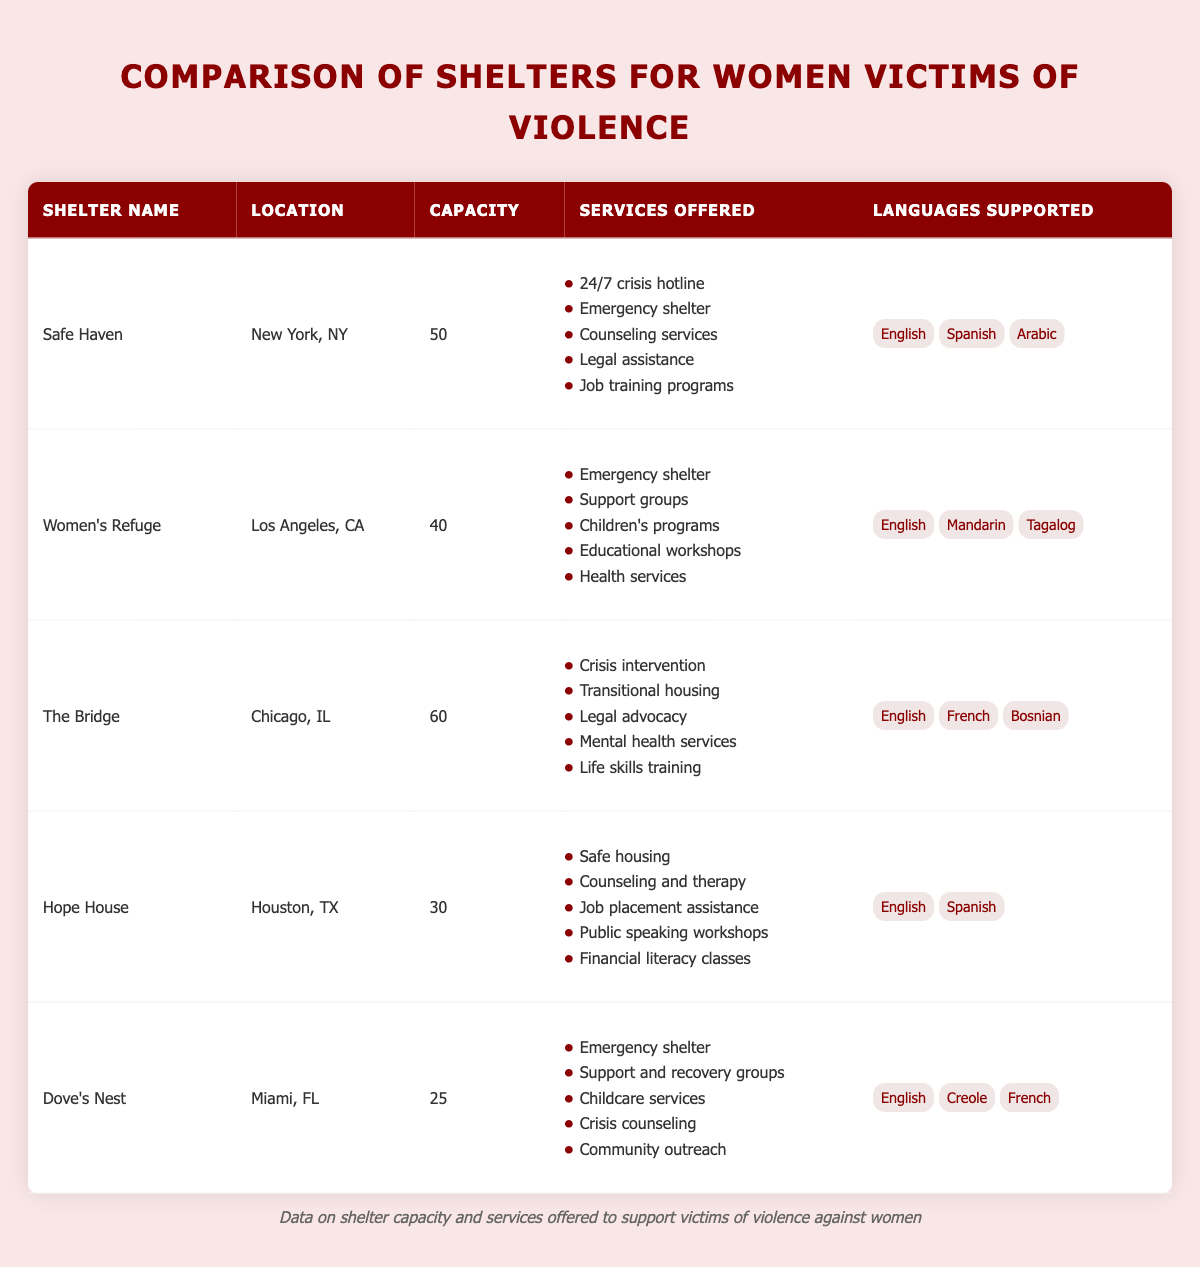What is the capacity of Safe Haven? The table lists Safe Haven under the "Shelter Name" column, and directly adjacent in the "Capacity" column, it states that the capacity of Safe Haven is 50.
Answer: 50 Which shelter offers the most services? To find which shelter provides the most services, we can count the number of services offered by each shelter. Safe Haven offers 5 services, Women’s Refuge offers 5, The Bridge offers 5, Hope House offers 5, and Dove’s Nest offers 5. They all offer the same number of services.
Answer: None Does Hope House provide job training programs? By checking the services offered under Hope House, it lists "Safe housing," "Counseling and therapy," "Job placement assistance," "Public speaking workshops," and "Financial literacy classes." Since there is no mention of job training programs, the answer is no.
Answer: No What is the total capacity of all shelters combined? To find the total capacity, sum the capacities of all shelters: 50 (Safe Haven) + 40 (Women’s Refuge) + 60 (The Bridge) + 30 (Hope House) + 25 (Dove’s Nest) = 205. Therefore, the total capacity of all shelters combined is 205.
Answer: 205 Is legal assistance offered at Dove's Nest? Looking at the services provided by Dove’s Nest, it lists "Emergency shelter," "Support and recovery groups," "Childcare services," "Crisis counseling," and "Community outreach." Legal assistance is not included in that list, so the answer is no.
Answer: No Which shelter has the highest language support diversity? The highest language support diversity can be determined by looking at the "Languages Supported" for each shelter. Safe Haven offers 3 languages (English, Spanish, Arabic), Women’s Refuge offers 3 languages (English, Mandarin, Tagalog), The Bridge offers 3 languages (English, French, Bosnian), Hope House offers 2 languages (English, Spanish), and Dove’s Nest offers 3 languages (English, Creole, French). Safe Haven, Women’s Refuge, The Bridge, and Dove’s Nest all have the same highest diversity with 3 languages.
Answer: Safe Haven, Women’s Refuge, The Bridge, Dove’s Nest What services does The Bridge offer that are not provided by Hope House? To answer this, we look at the services offered by both shelters. The Bridge offers "Crisis intervention," "Transitional housing," "Legal advocacy," "Mental health services," and "Life skills training," while Hope House offers "Safe housing," "Counseling and therapy," "Job placement assistance," "Public speaking workshops," and "Financial literacy classes." The unique services offered by The Bridge that are not offered by Hope House are "Crisis intervention," "Transitional housing," "Legal advocacy," and "Mental health services."
Answer: Crisis intervention, Transitional housing, Legal advocacy, Mental health services 